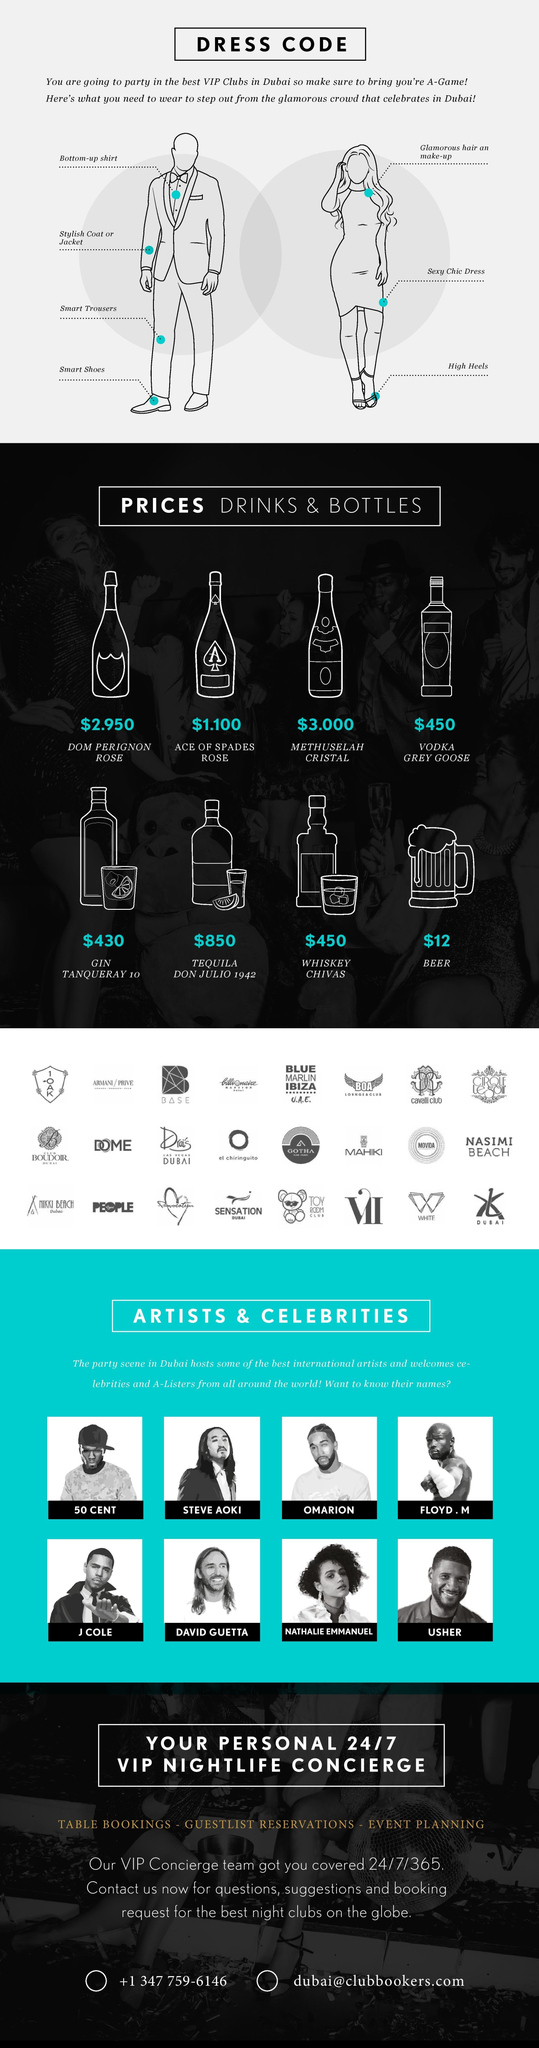Mention a couple of crucial points in this snapshot. Nathalie Emmanuel is the only female artist featured. The cost of the most affordable drink in the VIP club is $1,100. The costliest drink available at the VIP club is Tequila Don Julio 1942. The artist who is placed on the second row and first from the right is Usher. It is known that eight types of alcoholic drinks are sold in the VIP clubs of Dubai. 